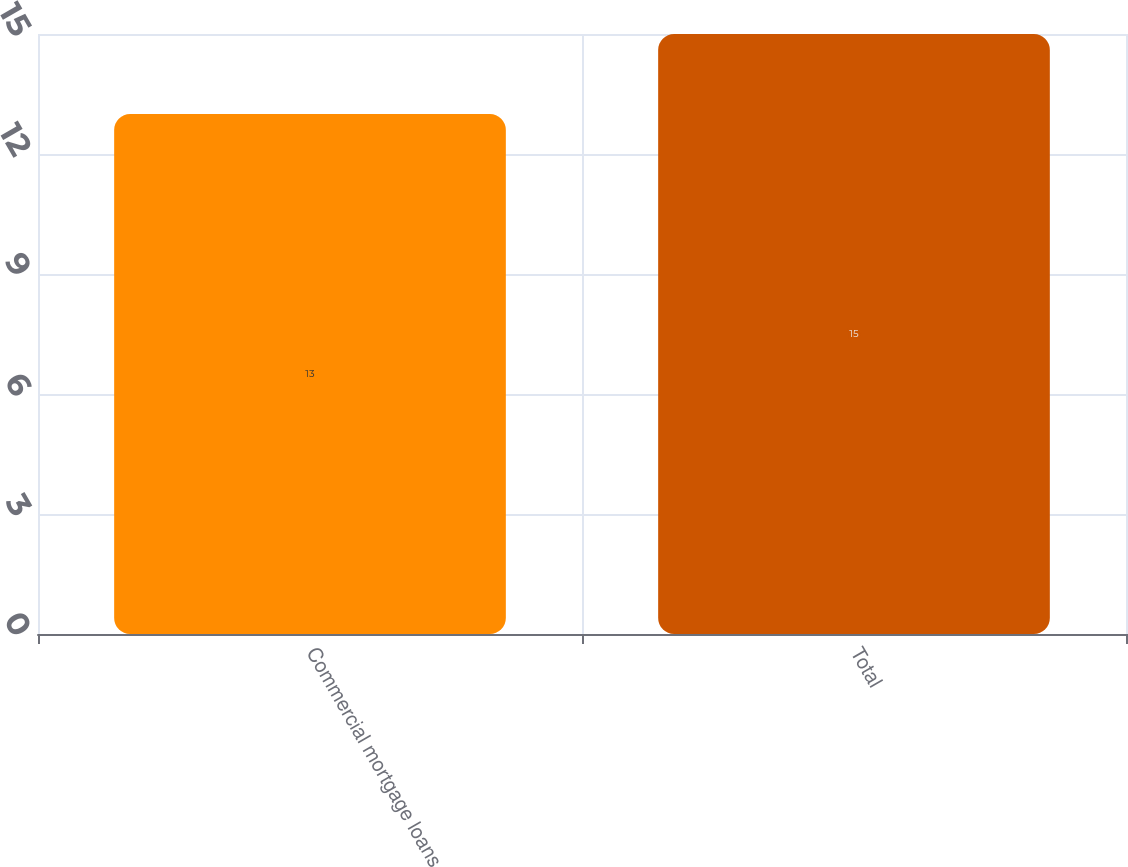Convert chart. <chart><loc_0><loc_0><loc_500><loc_500><bar_chart><fcel>Commercial mortgage loans<fcel>Total<nl><fcel>13<fcel>15<nl></chart> 